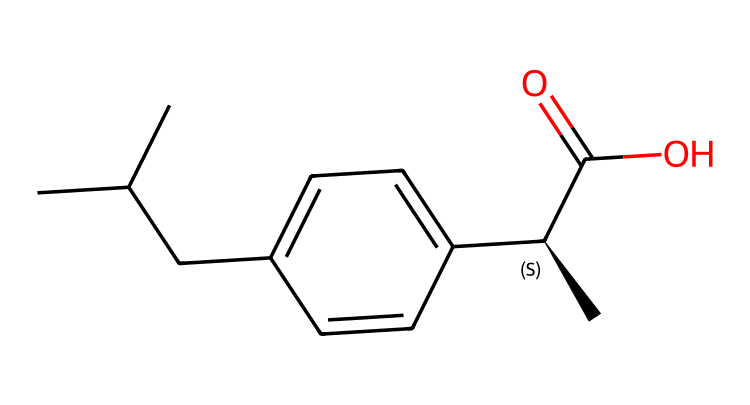what is the name of this chemical? The SMILES representation corresponds to ibuprofen, which is a common nonsteroidal anti-inflammatory drug used to relieve pain and reduce inflammation.
Answer: ibuprofen how many carbon atoms are in the structure? By analyzing the SMILES representation, we see six carbon atoms in the aromatic ring and six more in the aliphatic chain, totaling twelve carbon atoms.
Answer: twelve does this chemical contain a carboxylic acid group? The presence of the "C(=O)O" portion in the SMILES indicates that it includes a carboxylic acid group, which is characteristic of NSAIDs for their beneficial effects.
Answer: yes what type of functional group is present in ibuprofen? The chemical structure reveals that ibuprofen contains a carboxylic acid group as well as an alkyl and an aromatic group, making it a carboxylic acid.
Answer: carboxylic acid is this compound a solid or liquid at room temperature? Based on the properties of similar compounds and the structure of ibuprofen, it is typically a solid at room temperature due to its crystalline nature.
Answer: solid how many rings are present in this chemical structure? The SMILES indicates that there is one aromatic ring in the chemical structure, which is directly observable in the representation.
Answer: one what type of reaction would a carboxylic acid like ibuprofen typically undergo? Carboxylic acids can undergo various reactions, but they are particularly known for undergoing esterification reactions, reacting with alcohols to form esters.
Answer: esterification 